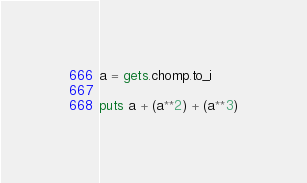<code> <loc_0><loc_0><loc_500><loc_500><_Ruby_>a = gets.chomp.to_i

puts a + (a**2) + (a**3)</code> 